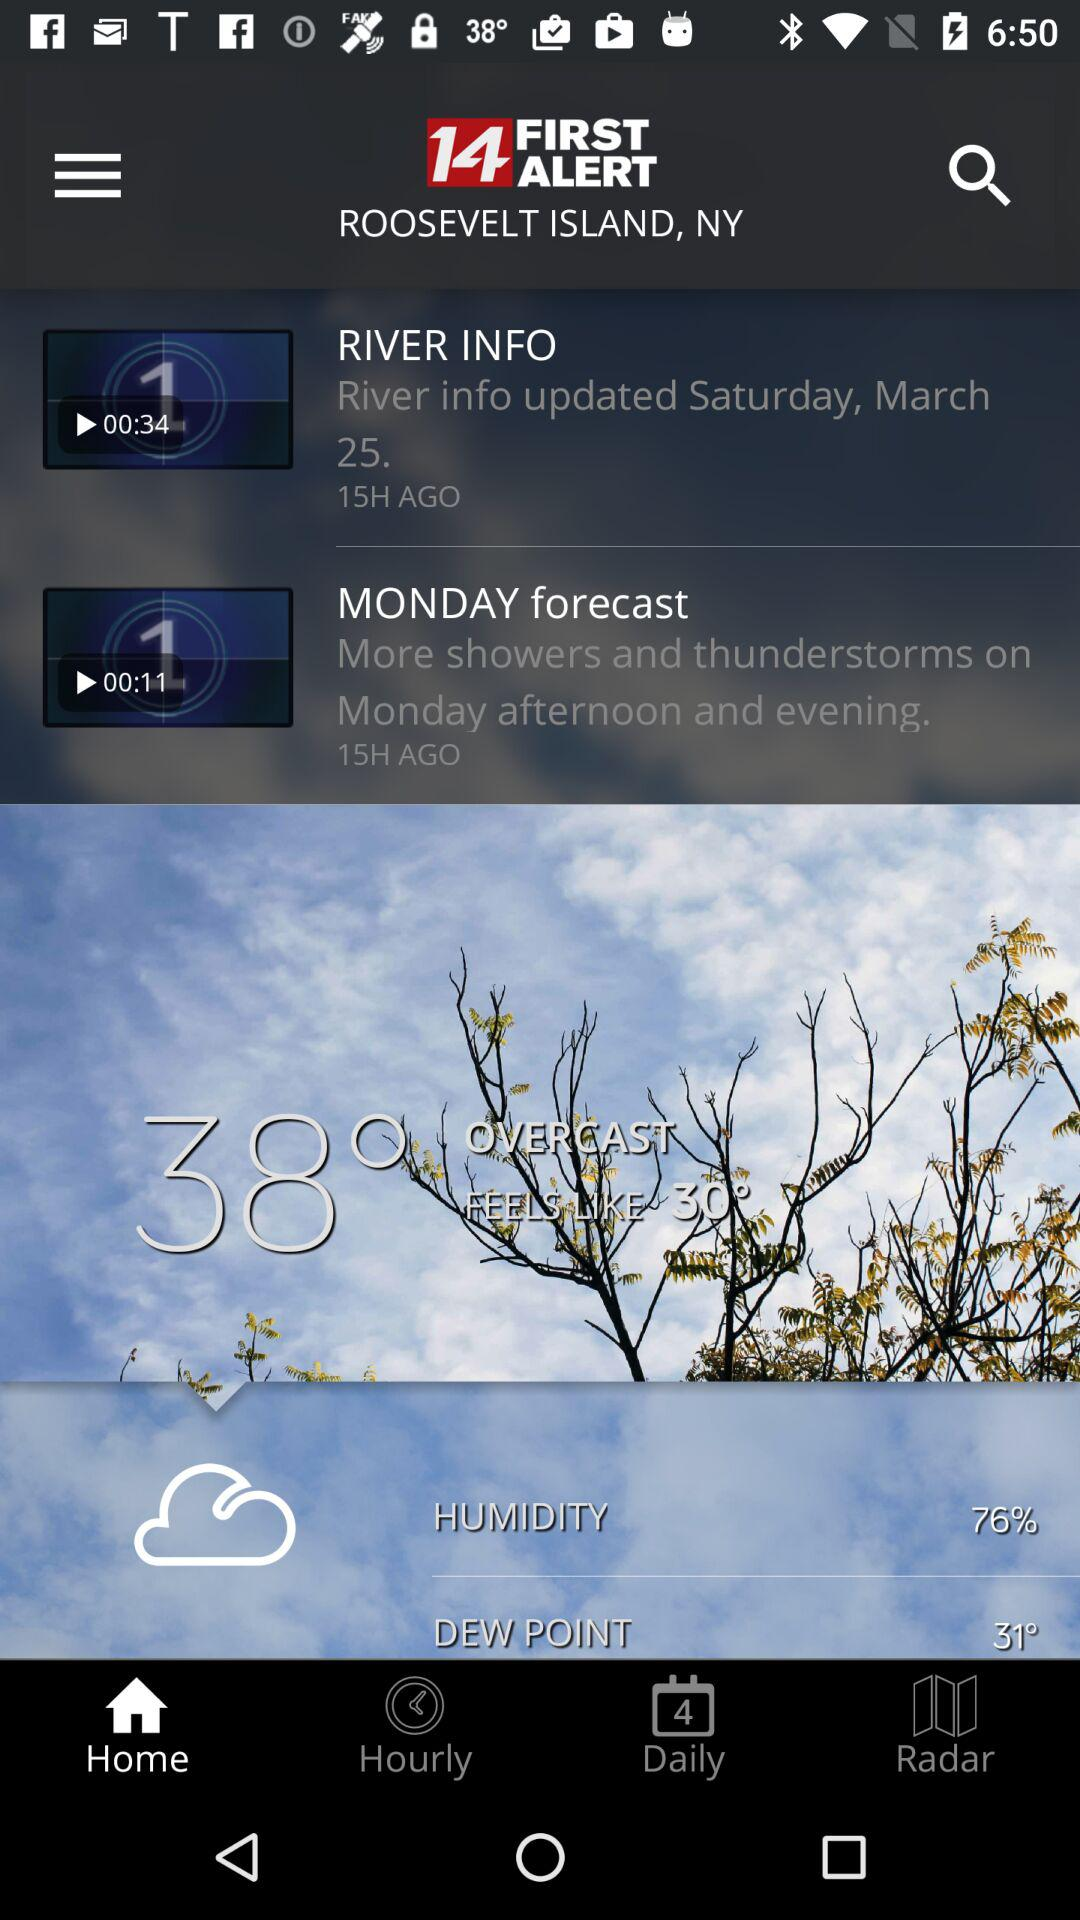How many hours ago was the last update to the river info?
Answer the question using a single word or phrase. 15H AGO 